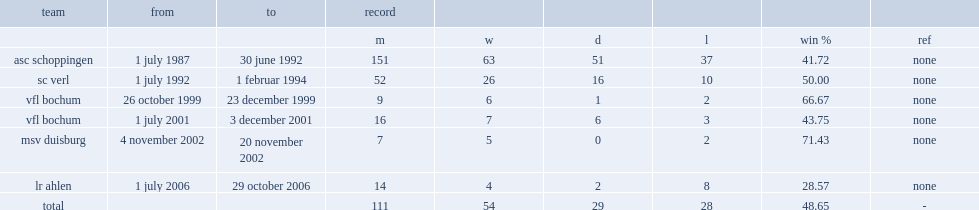When has bernard dietz been a coach of asc schoppingen? 1 july 1987 30 june 1992. 